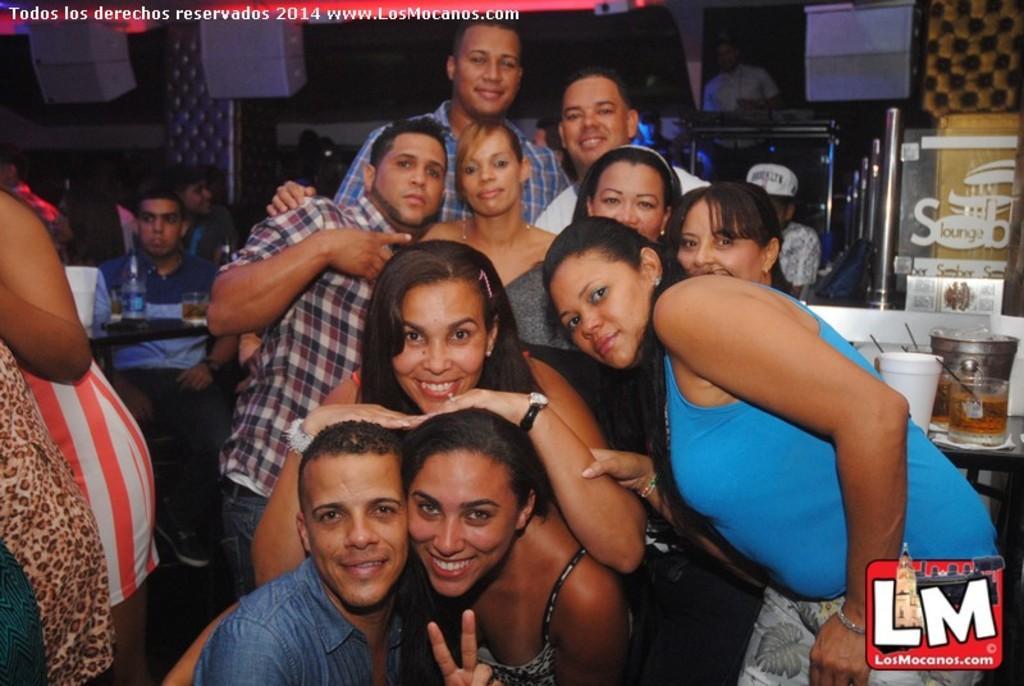Could you give a brief overview of what you see in this image? Group of people are highlighted in this picture. These group of people are giving some stills. Few people are smiling. The woman kept her 2 hand on this 2 persons head. This person sat on a chair. In-front of this man there is a table, above the table there is the bottle. Poles are in silver color. On a table there is a container jar. 